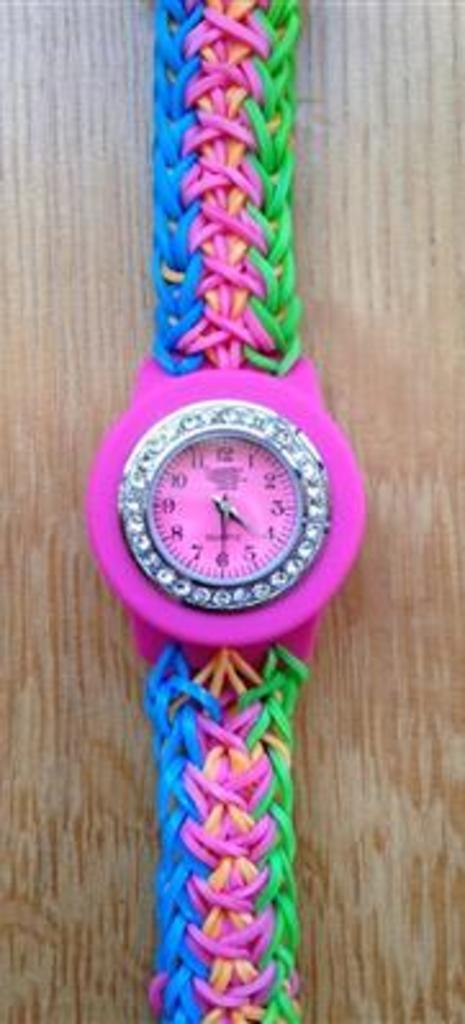<image>
Share a concise interpretation of the image provided. Colorful stopwatch with the hands set at 4 and 6. 